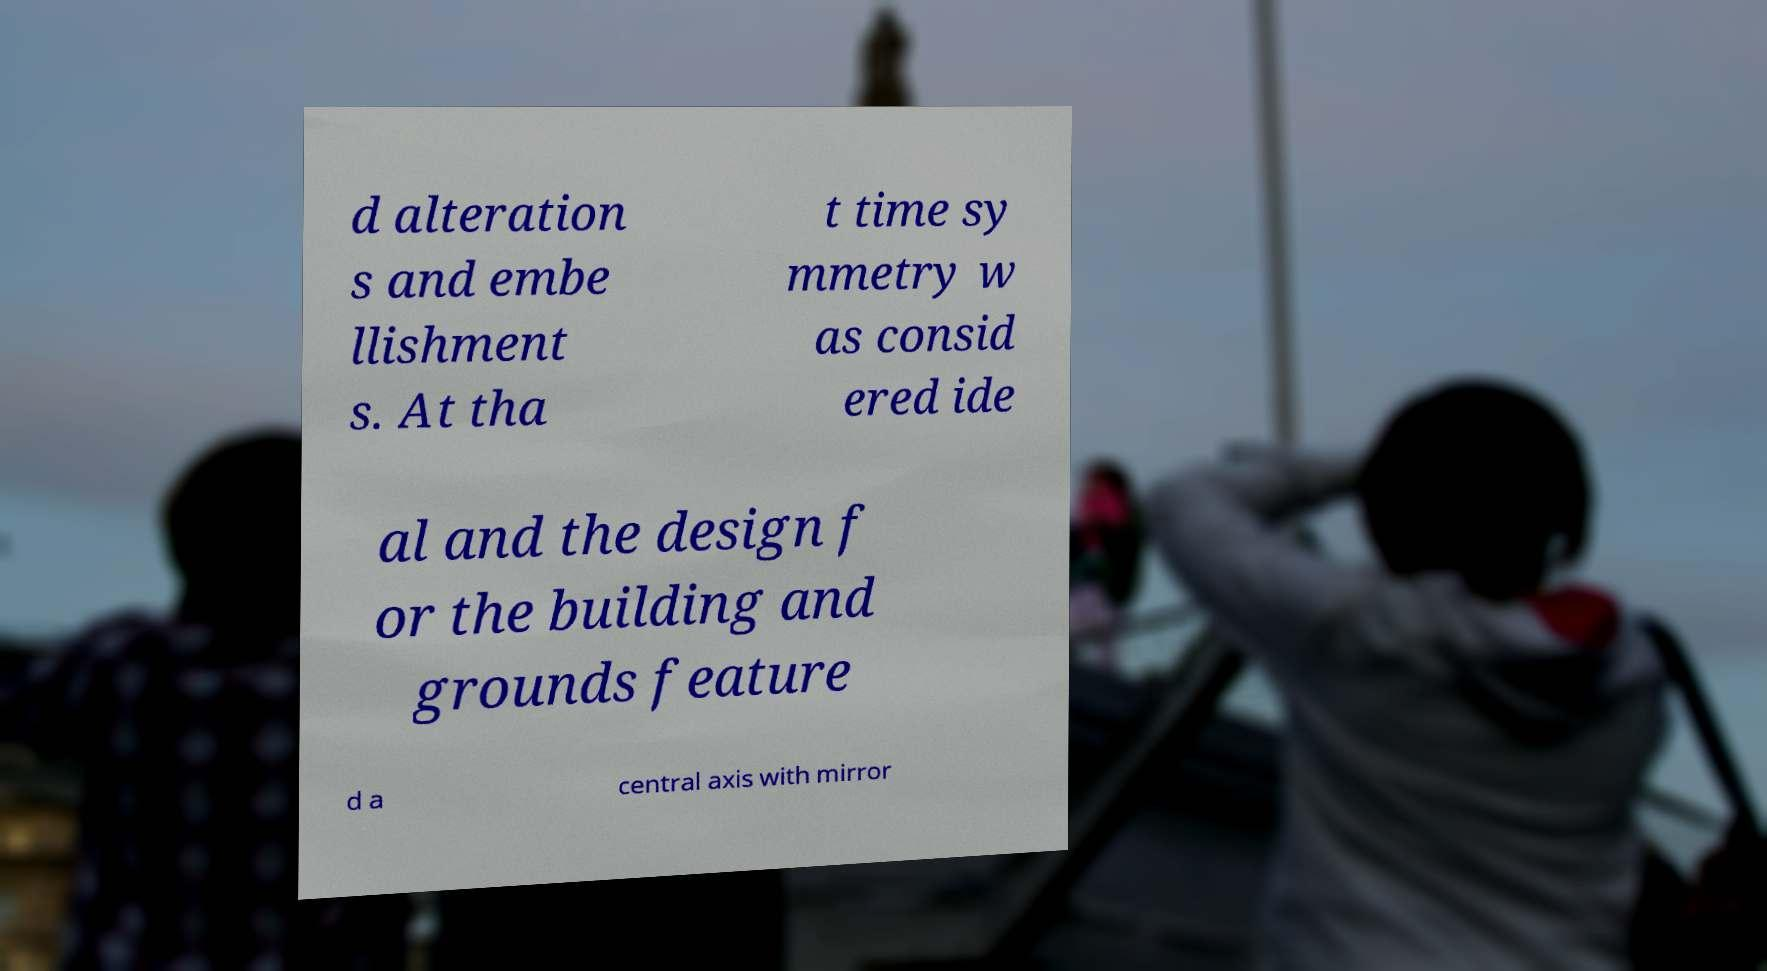There's text embedded in this image that I need extracted. Can you transcribe it verbatim? d alteration s and embe llishment s. At tha t time sy mmetry w as consid ered ide al and the design f or the building and grounds feature d a central axis with mirror 